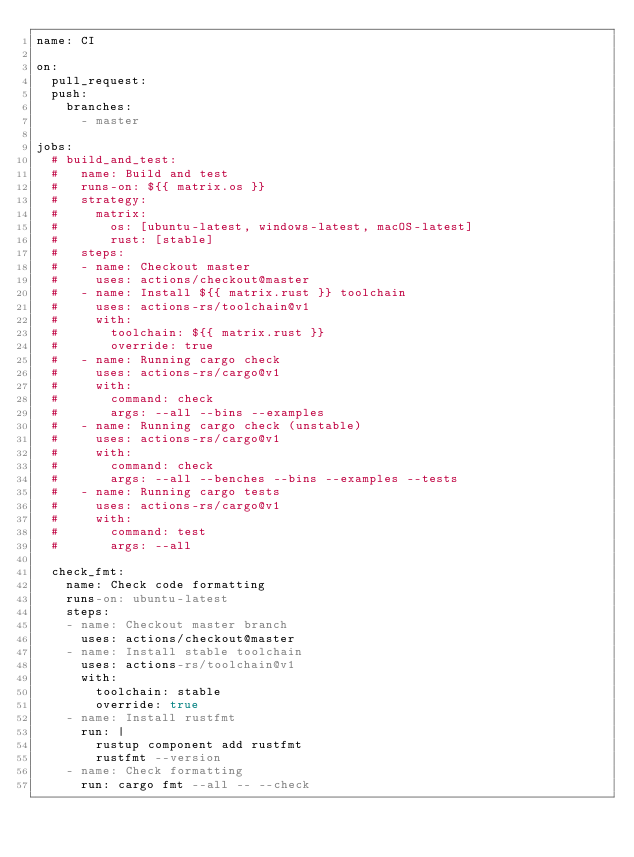Convert code to text. <code><loc_0><loc_0><loc_500><loc_500><_YAML_>name: CI

on:
  pull_request:
  push:
    branches:
      - master

jobs:
  # build_and_test:
  #   name: Build and test
  #   runs-on: ${{ matrix.os }}
  #   strategy:
  #     matrix:
  #       os: [ubuntu-latest, windows-latest, macOS-latest]
  #       rust: [stable]
  #   steps:
  #   - name: Checkout master
  #     uses: actions/checkout@master
  #   - name: Install ${{ matrix.rust }} toolchain
  #     uses: actions-rs/toolchain@v1
  #     with:
  #       toolchain: ${{ matrix.rust }}
  #       override: true
  #   - name: Running cargo check
  #     uses: actions-rs/cargo@v1
  #     with:
  #       command: check
  #       args: --all --bins --examples
  #   - name: Running cargo check (unstable)
  #     uses: actions-rs/cargo@v1
  #     with:
  #       command: check
  #       args: --all --benches --bins --examples --tests
  #   - name: Running cargo tests
  #     uses: actions-rs/cargo@v1
  #     with:
  #       command: test
  #       args: --all

  check_fmt:
    name: Check code formatting
    runs-on: ubuntu-latest
    steps:
    - name: Checkout master branch
      uses: actions/checkout@master
    - name: Install stable toolchain
      uses: actions-rs/toolchain@v1
      with:
        toolchain: stable
        override: true
    - name: Install rustfmt
      run: |
        rustup component add rustfmt
        rustfmt --version
    - name: Check formatting
      run: cargo fmt --all -- --check
</code> 